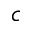<formula> <loc_0><loc_0><loc_500><loc_500>c</formula> 